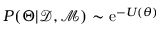Convert formula to latex. <formula><loc_0><loc_0><loc_500><loc_500>P ( \Theta | \mathcal { D } , \mathcal { M } ) \sim e ^ { - U ( \theta ) }</formula> 